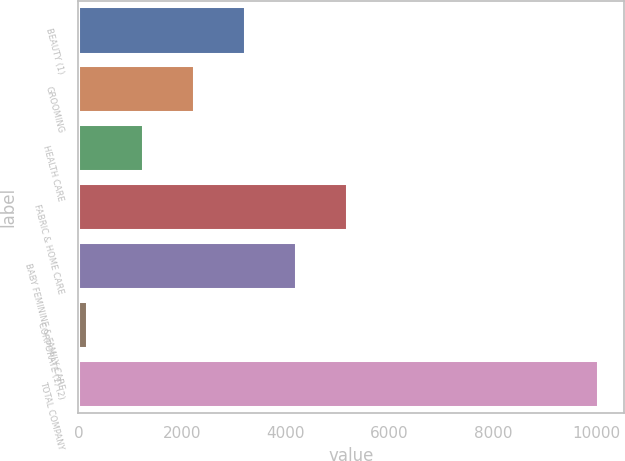Convert chart. <chart><loc_0><loc_0><loc_500><loc_500><bar_chart><fcel>BEAUTY (1)<fcel>GROOMING<fcel>HEALTH CARE<fcel>FABRIC & HOME CARE<fcel>BABY FEMININE & FAMILY CARE<fcel>CORPORATE (1) (2)<fcel>TOTAL COMPANY<nl><fcel>3220.6<fcel>2235.3<fcel>1250<fcel>5191.2<fcel>4205.9<fcel>174<fcel>10027<nl></chart> 